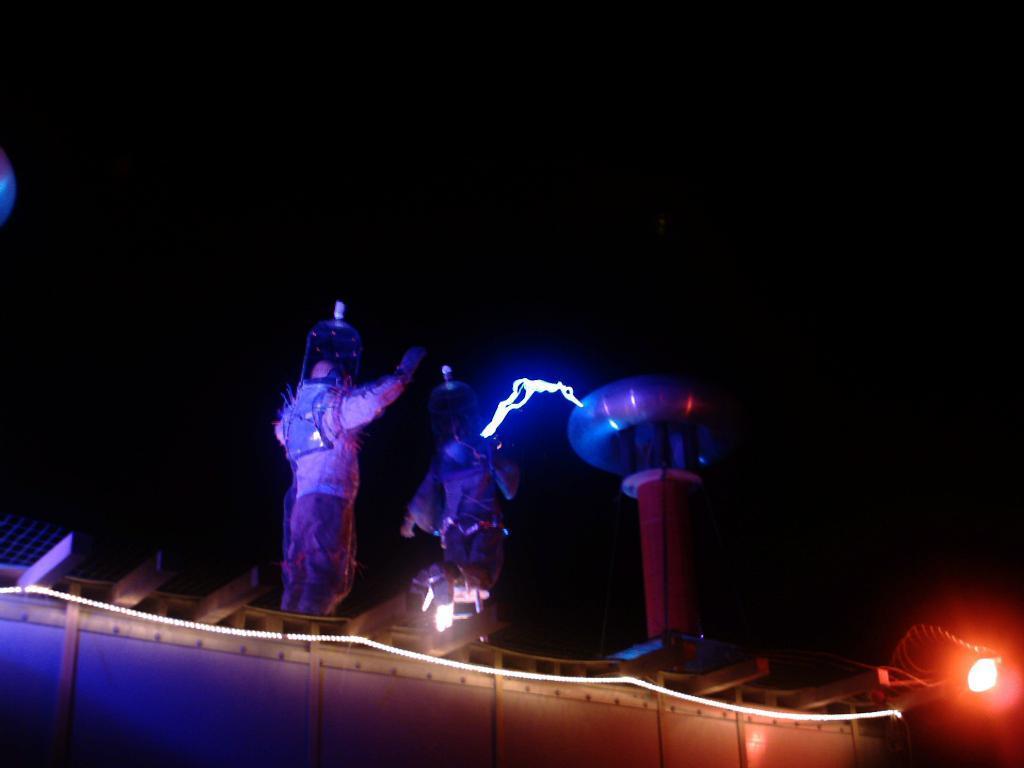Describe this image in one or two sentences. In this image there is an object in the foreground. There are two persons. There is a light on the right side. There is a dark background. 